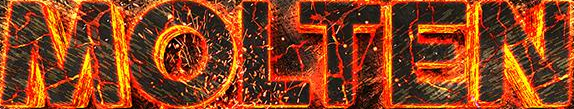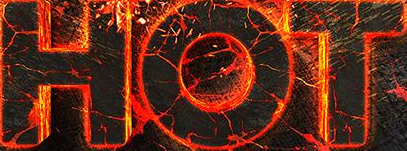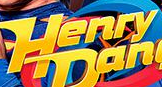What text is displayed in these images sequentially, separated by a semicolon? MOLTEN; HOT; Henry 